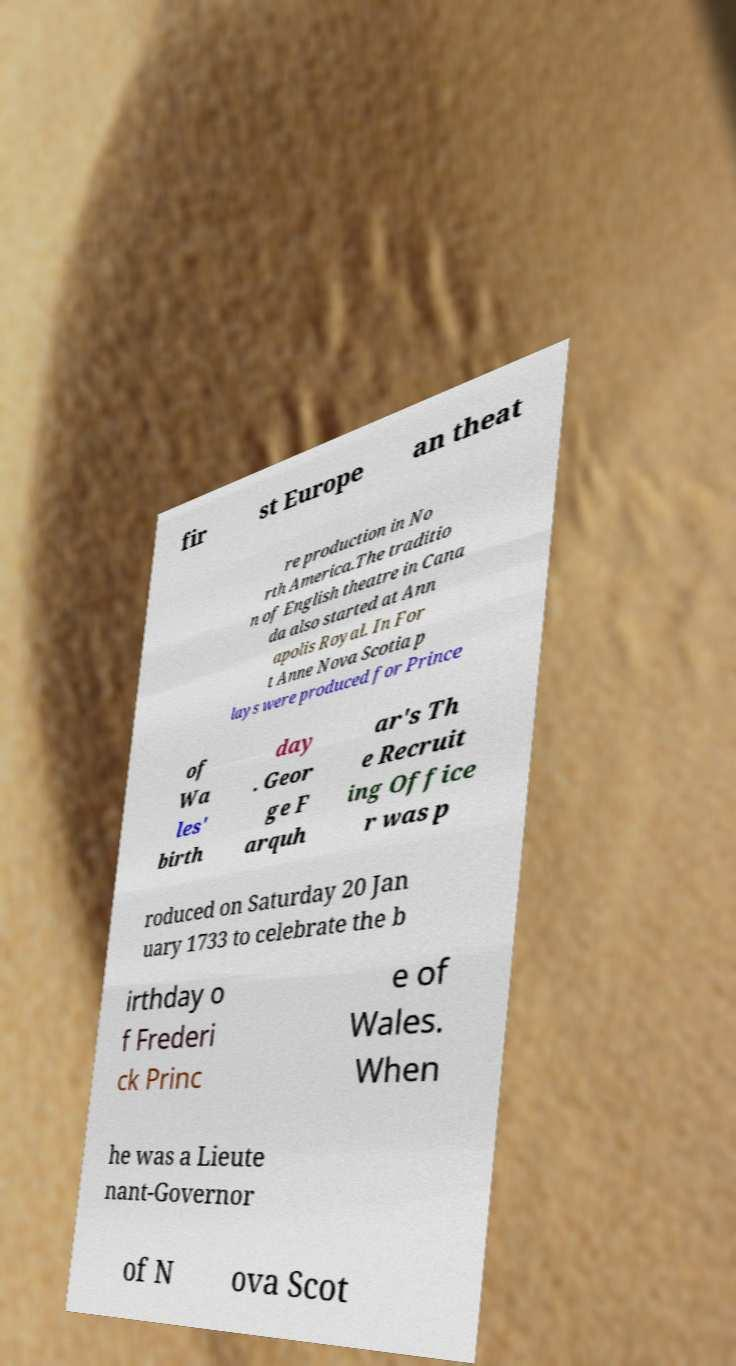Please read and relay the text visible in this image. What does it say? fir st Europe an theat re production in No rth America.The traditio n of English theatre in Cana da also started at Ann apolis Royal. In For t Anne Nova Scotia p lays were produced for Prince of Wa les' birth day . Geor ge F arquh ar's Th e Recruit ing Office r was p roduced on Saturday 20 Jan uary 1733 to celebrate the b irthday o f Frederi ck Princ e of Wales. When he was a Lieute nant-Governor of N ova Scot 